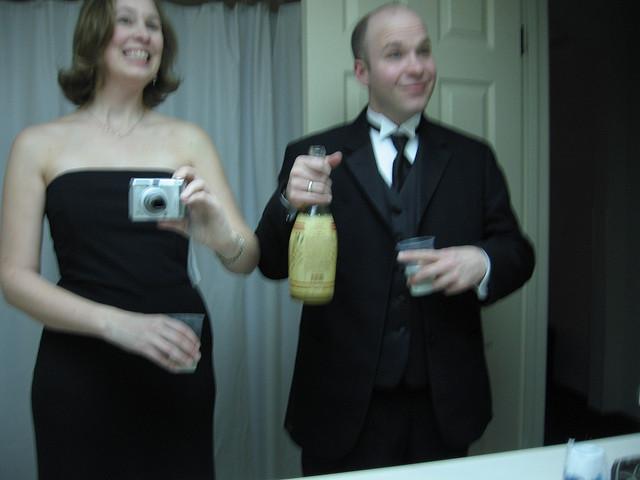What is the person holding?
Answer briefly. Bottle. What is the girl holding?
Short answer required. Camera. What is the woman holding in her left hand?
Write a very short answer. Camera. What are these people playing with?
Answer briefly. Camera. What kind of dress is wearing?
Quick response, please. Fancy. Is the dress white?
Short answer required. No. Is the woman wearing a suit?
Write a very short answer. No. What is the woman holding?
Keep it brief. Camera. Are they dressed for a formal occasion?
Answer briefly. Yes. Where are the man's hands?
Write a very short answer. In front of him. Is the man spinning a ball on his finger?
Concise answer only. No. What is in the guys right hand?
Answer briefly. Bottle. Are they competing?
Write a very short answer. No. What fingers are pointing?
Give a very brief answer. Index and middle. Is this an official occasion?
Short answer required. Yes. Is there a third person nearby?
Answer briefly. No. Who is taking this photograph?
Write a very short answer. Woman. Is the man wearing a bow tie or a regular tie?
Concise answer only. Regular. 